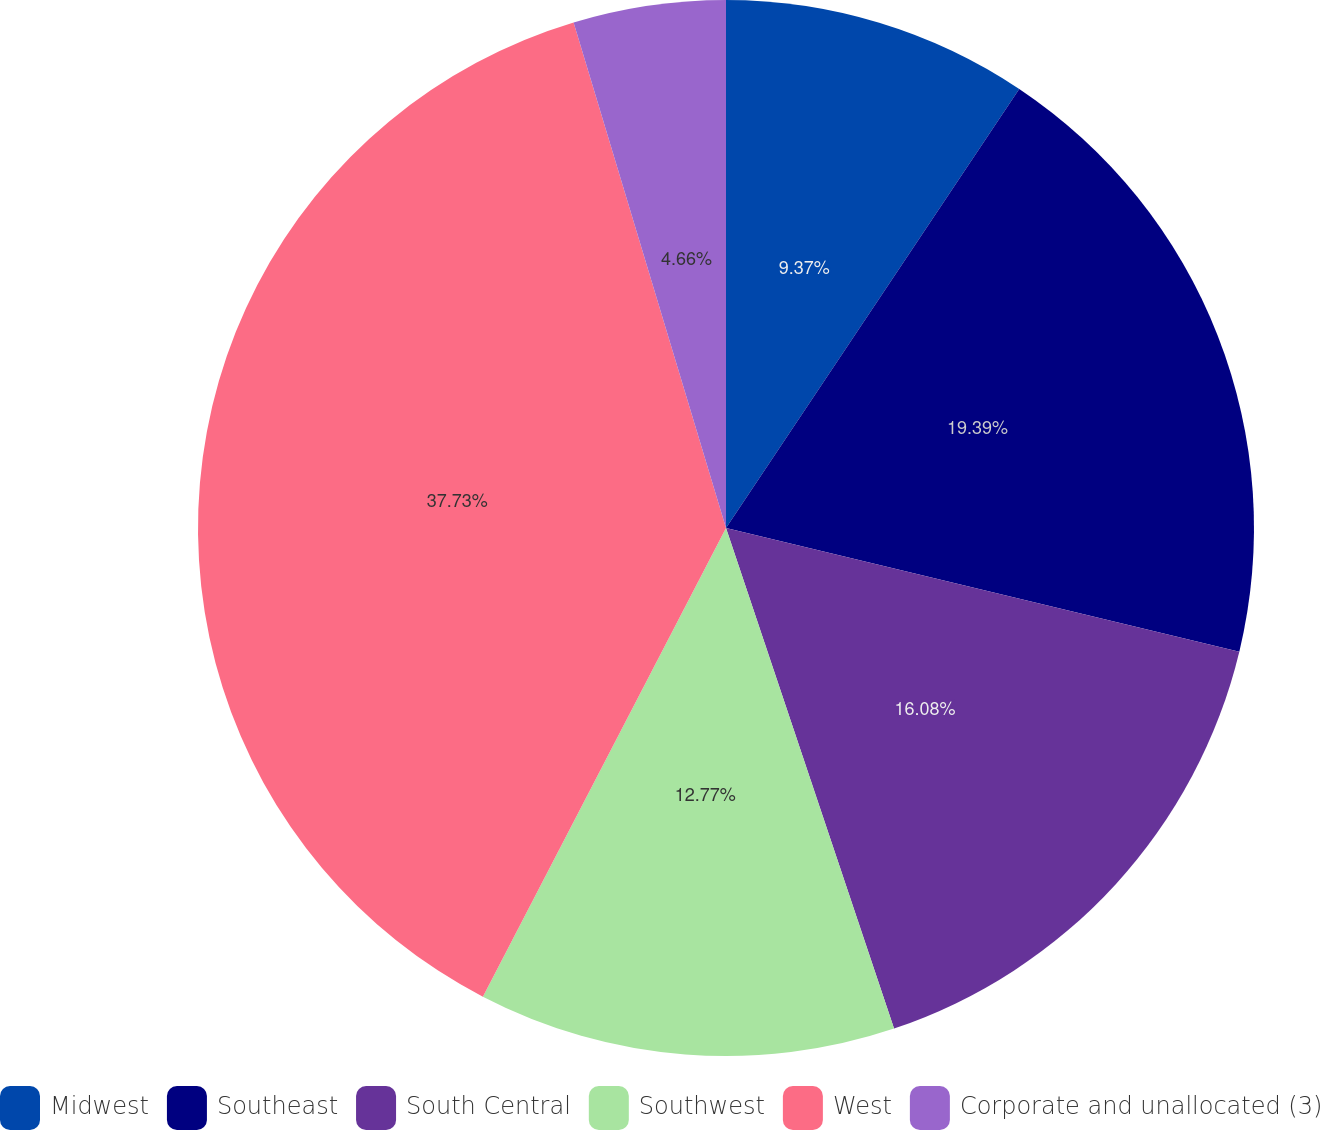Convert chart to OTSL. <chart><loc_0><loc_0><loc_500><loc_500><pie_chart><fcel>Midwest<fcel>Southeast<fcel>South Central<fcel>Southwest<fcel>West<fcel>Corporate and unallocated (3)<nl><fcel>9.37%<fcel>19.39%<fcel>16.08%<fcel>12.77%<fcel>37.72%<fcel>4.66%<nl></chart> 